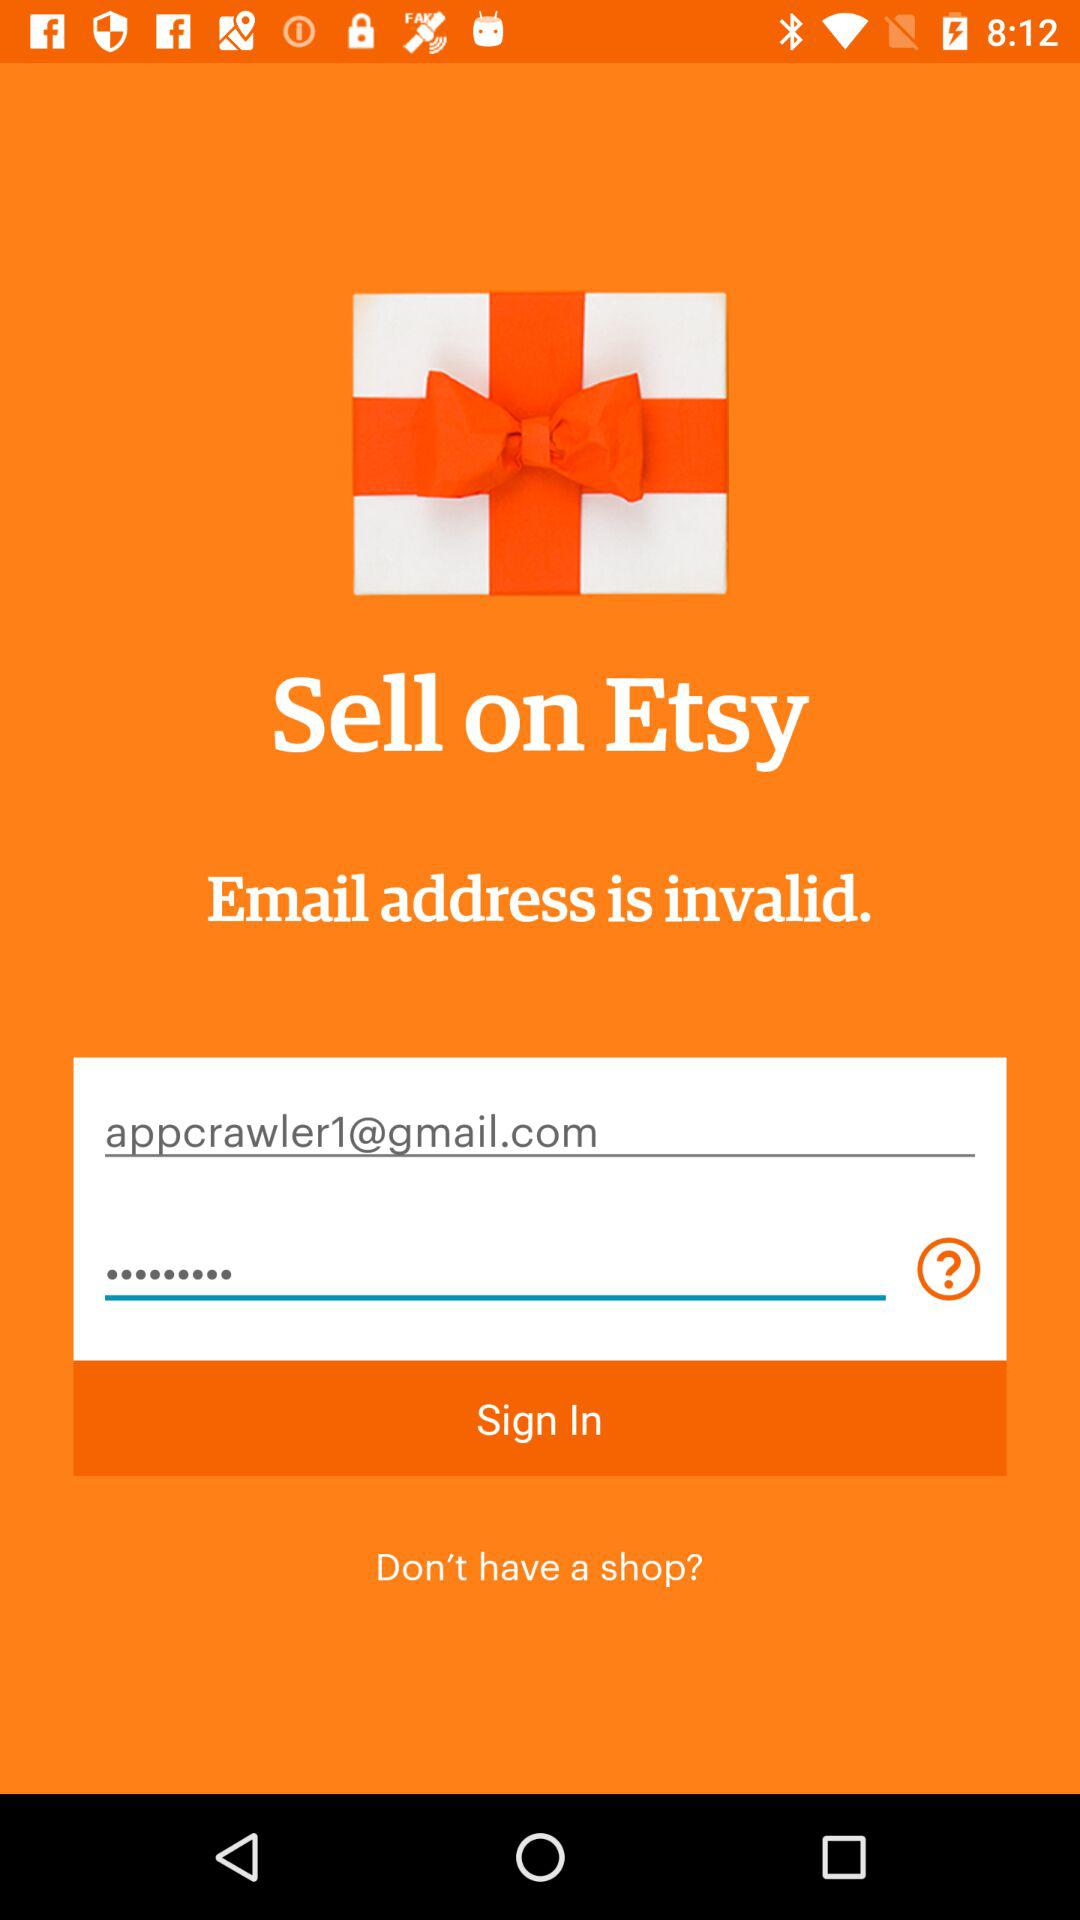What is the name of the application? The name of the application is "Etsy". 